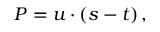<formula> <loc_0><loc_0><loc_500><loc_500>P = u \cdot ( s - t ) \, ,</formula> 